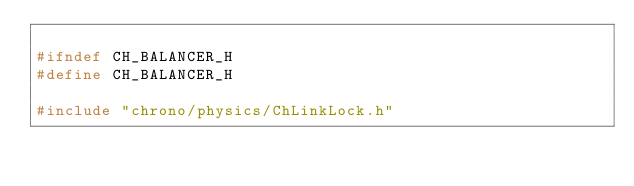<code> <loc_0><loc_0><loc_500><loc_500><_C_>
#ifndef CH_BALANCER_H
#define CH_BALANCER_H

#include "chrono/physics/ChLinkLock.h"
</code> 